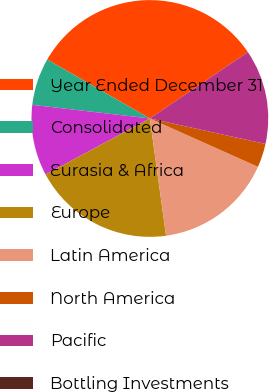Convert chart. <chart><loc_0><loc_0><loc_500><loc_500><pie_chart><fcel>Year Ended December 31<fcel>Consolidated<fcel>Eurasia & Africa<fcel>Europe<fcel>Latin America<fcel>North America<fcel>Pacific<fcel>Bottling Investments<nl><fcel>32.22%<fcel>6.46%<fcel>9.68%<fcel>19.34%<fcel>16.12%<fcel>3.24%<fcel>12.9%<fcel>0.03%<nl></chart> 